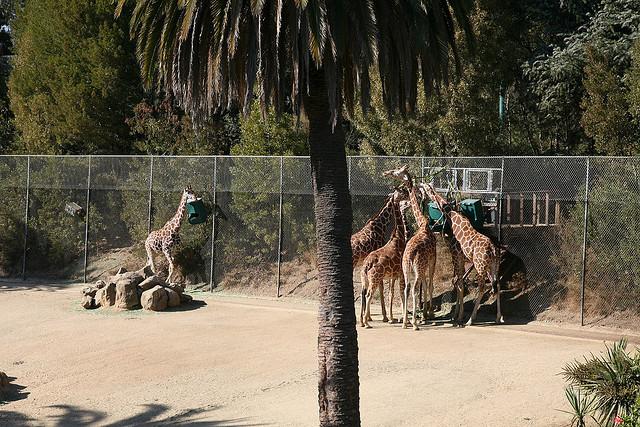Can the giraffe's jump this fence?
Write a very short answer. No. Are the giraffes drinking water?
Keep it brief. Yes. How many giraffes are here?
Write a very short answer. 5. How many giraffes?
Short answer required. 5. 